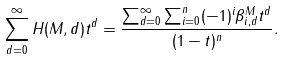Convert formula to latex. <formula><loc_0><loc_0><loc_500><loc_500>\sum _ { d = 0 } ^ { \infty } H ( M , d ) t ^ { d } = \frac { \sum _ { d = 0 } ^ { \infty } \sum _ { i = 0 } ^ { n } ( - 1 ) ^ { i } \beta ^ { M } _ { i , d } t ^ { d } } { ( 1 - t ) ^ { n } } .</formula> 